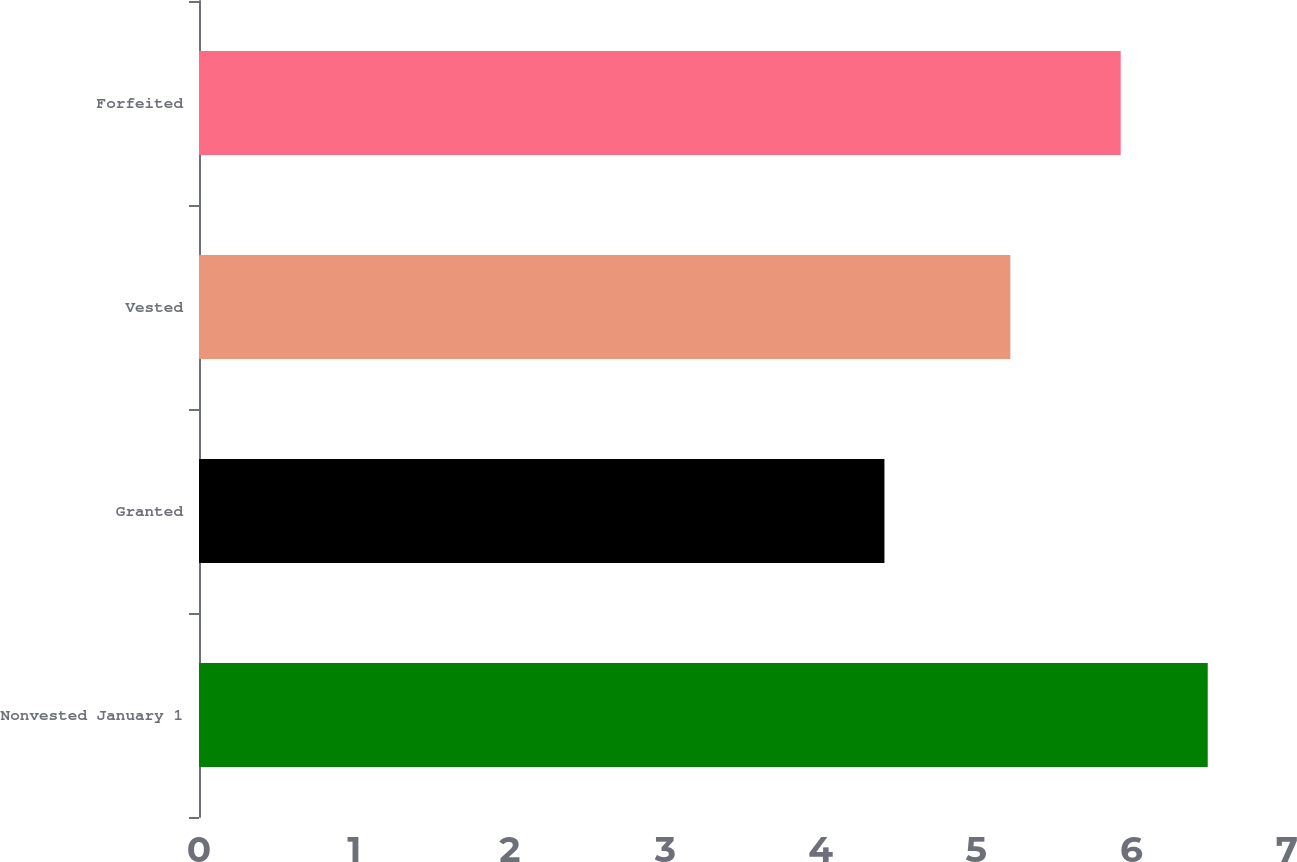Convert chart. <chart><loc_0><loc_0><loc_500><loc_500><bar_chart><fcel>Nonvested January 1<fcel>Granted<fcel>Vested<fcel>Forfeited<nl><fcel>6.49<fcel>4.41<fcel>5.22<fcel>5.93<nl></chart> 